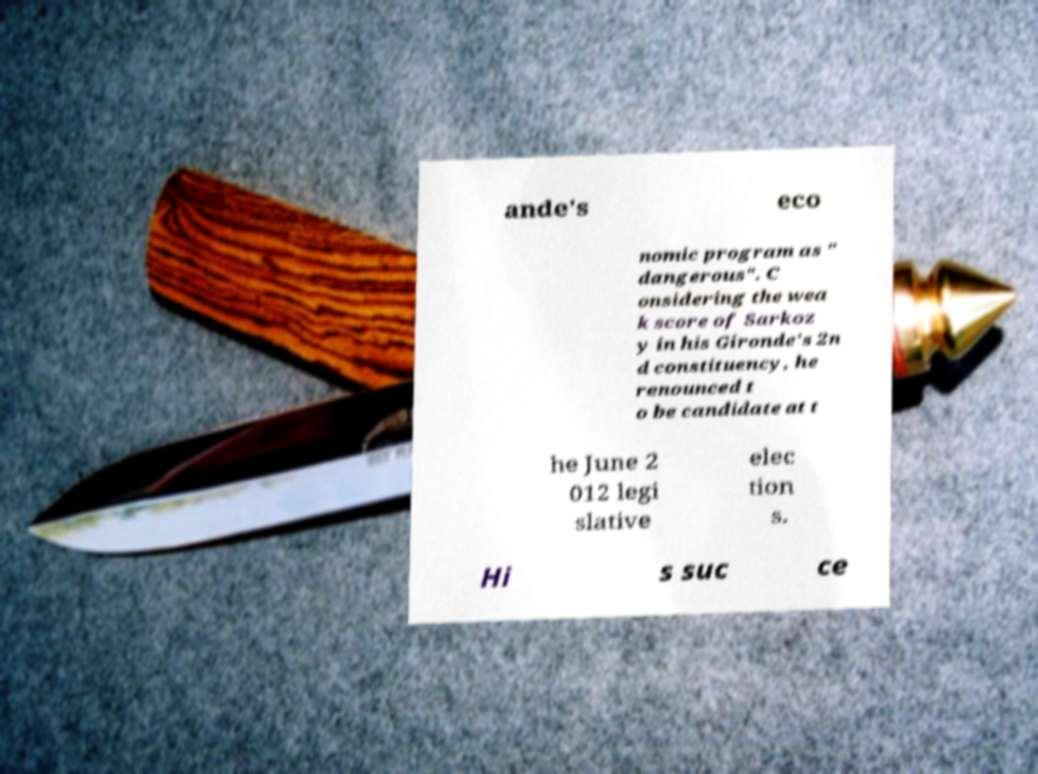There's text embedded in this image that I need extracted. Can you transcribe it verbatim? ande's eco nomic program as " dangerous". C onsidering the wea k score of Sarkoz y in his Gironde's 2n d constituency, he renounced t o be candidate at t he June 2 012 legi slative elec tion s. Hi s suc ce 